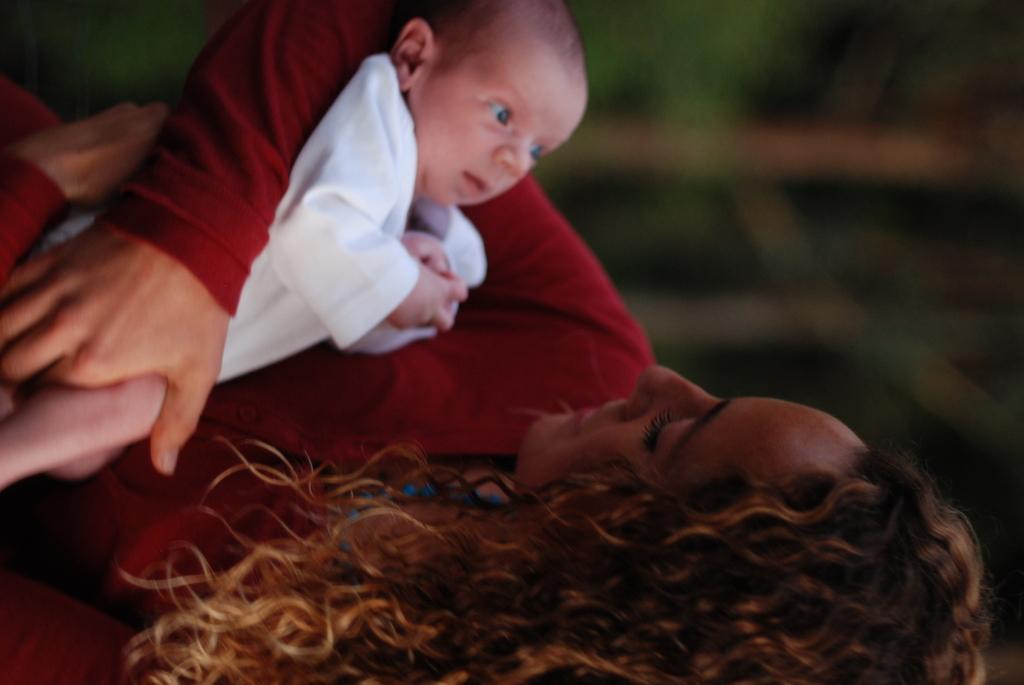In one or two sentences, can you explain what this image depicts? In the picture we can see a woman holding a child, the woman is wearing a red dress and a child with white dress and a woman is having a curly hair which is brown in color. 